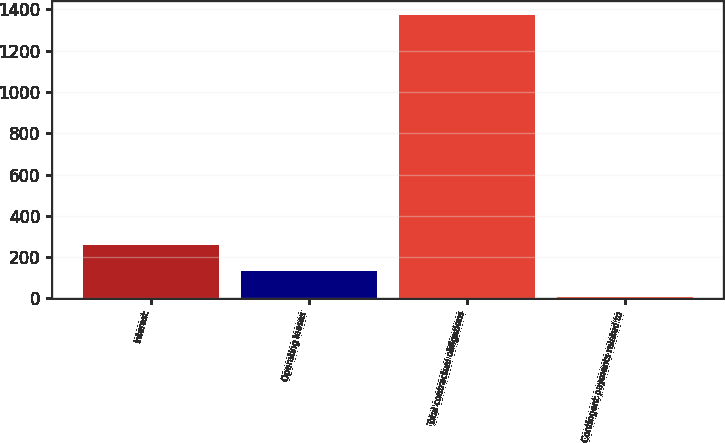Convert chart to OTSL. <chart><loc_0><loc_0><loc_500><loc_500><bar_chart><fcel>Interest<fcel>Operating leases<fcel>Total contractual obligations<fcel>Contingent payments related to<nl><fcel>258.4<fcel>133.7<fcel>1371.7<fcel>9<nl></chart> 